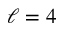<formula> <loc_0><loc_0><loc_500><loc_500>\ell = 4</formula> 